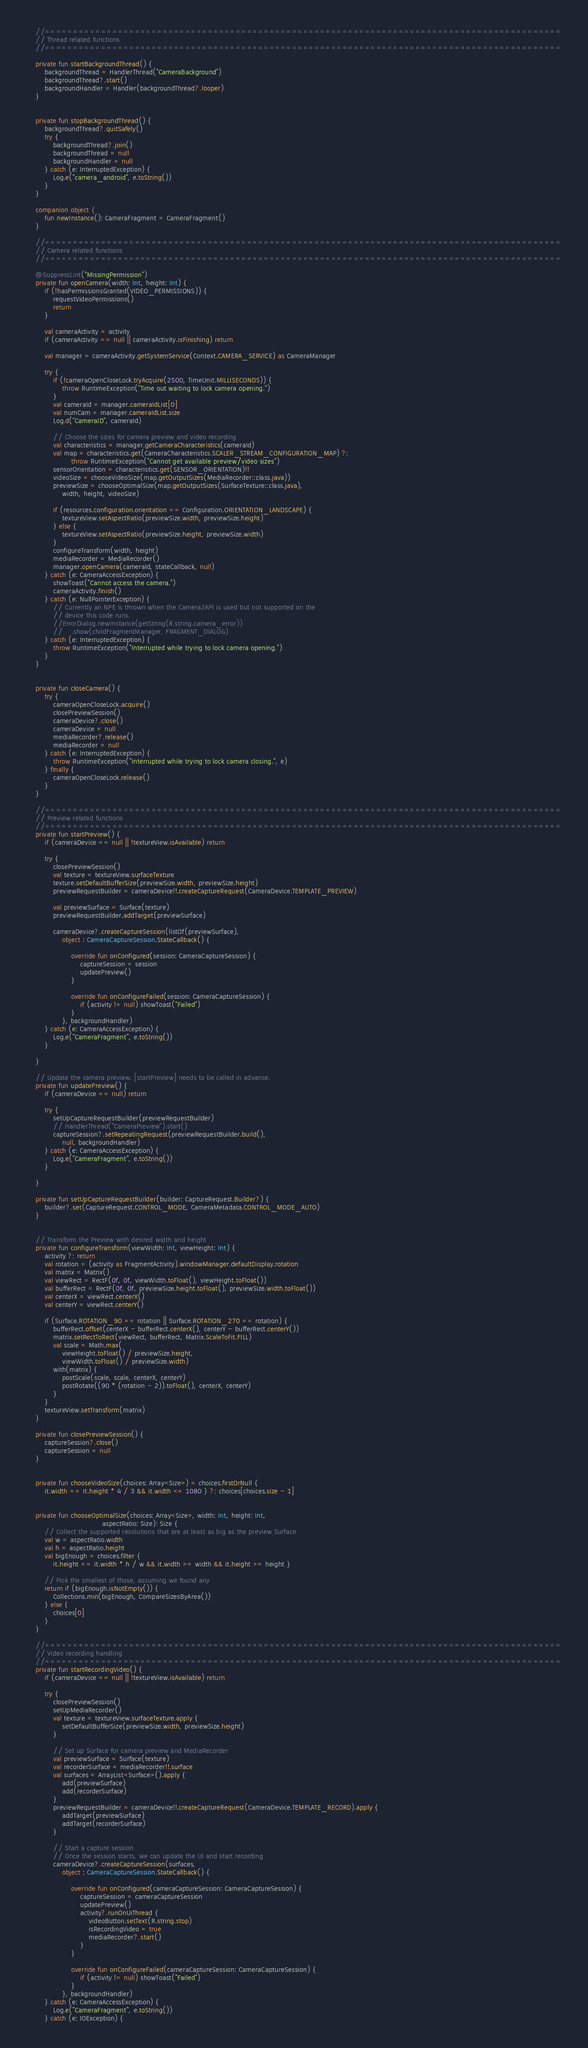Convert code to text. <code><loc_0><loc_0><loc_500><loc_500><_Kotlin_>    //============================================================================================
    // Thread related functions
    //============================================================================================

    private fun startBackgroundThread() {
        backgroundThread = HandlerThread("CameraBackground")
        backgroundThread?.start()
        backgroundHandler = Handler(backgroundThread?.looper)
    }


    private fun stopBackgroundThread() {
        backgroundThread?.quitSafely()
        try {
            backgroundThread?.join()
            backgroundThread = null
            backgroundHandler = null
        } catch (e: InterruptedException) {
            Log.e("camera_android", e.toString())
        }
    }

    companion object {
        fun newInstance(): CameraFragment = CameraFragment()
    }

    //============================================================================================
    // Camera related functions
    //============================================================================================

    @SuppressLint("MissingPermission")
    private fun openCamera(width: Int, height: Int) {
        if (!hasPermissionsGranted(VIDEO_PERMISSIONS)) {
            requestVideoPermissions()
            return
        }

        val cameraActivity = activity
        if (cameraActivity == null || cameraActivity.isFinishing) return

        val manager = cameraActivity.getSystemService(Context.CAMERA_SERVICE) as CameraManager

        try {
            if (!cameraOpenCloseLock.tryAcquire(2500, TimeUnit.MILLISECONDS)) {
                throw RuntimeException("Time out waiting to lock camera opening.")
            }
            val cameraId = manager.cameraIdList[0]
            val numCam = manager.cameraIdList.size
            Log.d("CameraID", cameraId)

            // Choose the sizes for camera preview and video recording
            val characteristics = manager.getCameraCharacteristics(cameraId)
            val map = characteristics.get(CameraCharacteristics.SCALER_STREAM_CONFIGURATION_MAP) ?:
                    throw RuntimeException("Cannot get available preview/video sizes")
            sensorOrientation = characteristics.get(SENSOR_ORIENTATION)!!
            videoSize = chooseVideoSize(map.getOutputSizes(MediaRecorder::class.java))
            previewSize = chooseOptimalSize(map.getOutputSizes(SurfaceTexture::class.java),
                width, height, videoSize)

            if (resources.configuration.orientation == Configuration.ORIENTATION_LANDSCAPE) {
                textureView.setAspectRatio(previewSize.width, previewSize.height)
            } else {
                textureView.setAspectRatio(previewSize.height, previewSize.width)
            }
            configureTransform(width, height)
            mediaRecorder = MediaRecorder()
            manager.openCamera(cameraId, stateCallback, null)
        } catch (e: CameraAccessException) {
            showToast("Cannot access the camera.")
            cameraActivity.finish()
        } catch (e: NullPointerException) {
            // Currently an NPE is thrown when the Camera2API is used but not supported on the
            // device this code runs.
            //ErrorDialog.newInstance(getString(R.string.camera_error))
            //    .show(childFragmentManager, FRAGMENT_DIALOG)
        } catch (e: InterruptedException) {
            throw RuntimeException("Interrupted while trying to lock camera opening.")
        }
    }


    private fun closeCamera() {
        try {
            cameraOpenCloseLock.acquire()
            closePreviewSession()
            cameraDevice?.close()
            cameraDevice = null
            mediaRecorder?.release()
            mediaRecorder = null
        } catch (e: InterruptedException) {
            throw RuntimeException("Interrupted while trying to lock camera closing.", e)
        } finally {
            cameraOpenCloseLock.release()
        }
    }

    //============================================================================================
    // Preview related functions
    //============================================================================================
    private fun startPreview() {
        if (cameraDevice == null || !textureView.isAvailable) return

        try {
            closePreviewSession()
            val texture = textureView.surfaceTexture
            texture.setDefaultBufferSize(previewSize.width, previewSize.height)
            previewRequestBuilder = cameraDevice!!.createCaptureRequest(CameraDevice.TEMPLATE_PREVIEW)

            val previewSurface = Surface(texture)
            previewRequestBuilder.addTarget(previewSurface)

            cameraDevice?.createCaptureSession(listOf(previewSurface),
                object : CameraCaptureSession.StateCallback() {

                    override fun onConfigured(session: CameraCaptureSession) {
                        captureSession = session
                        updatePreview()
                    }

                    override fun onConfigureFailed(session: CameraCaptureSession) {
                        if (activity != null) showToast("Failed")
                    }
                }, backgroundHandler)
        } catch (e: CameraAccessException) {
            Log.e("CameraFragment", e.toString())
        }

    }

    // Update the camera preview. [startPreview] needs to be called in advance.
    private fun updatePreview() {
        if (cameraDevice == null) return

        try {
            setUpCaptureRequestBuilder(previewRequestBuilder)
            // HandlerThread("CameraPreview").start()
            captureSession?.setRepeatingRequest(previewRequestBuilder.build(),
                null, backgroundHandler)
        } catch (e: CameraAccessException) {
            Log.e("CameraFragment", e.toString())
        }

    }

    private fun setUpCaptureRequestBuilder(builder: CaptureRequest.Builder?) {
        builder?.set(CaptureRequest.CONTROL_MODE, CameraMetadata.CONTROL_MODE_AUTO)
    }


    // Transform the Preview with desired width and height
    private fun configureTransform(viewWidth: Int, viewHeight: Int) {
        activity ?: return
        val rotation = (activity as FragmentActivity).windowManager.defaultDisplay.rotation
        val matrix = Matrix()
        val viewRect = RectF(0f, 0f, viewWidth.toFloat(), viewHeight.toFloat())
        val bufferRect = RectF(0f, 0f, previewSize.height.toFloat(), previewSize.width.toFloat())
        val centerX = viewRect.centerX()
        val centerY = viewRect.centerY()

        if (Surface.ROTATION_90 == rotation || Surface.ROTATION_270 == rotation) {
            bufferRect.offset(centerX - bufferRect.centerX(), centerY - bufferRect.centerY())
            matrix.setRectToRect(viewRect, bufferRect, Matrix.ScaleToFit.FILL)
            val scale = Math.max(
                viewHeight.toFloat() / previewSize.height,
                viewWidth.toFloat() / previewSize.width)
            with(matrix) {
                postScale(scale, scale, centerX, centerY)
                postRotate((90 * (rotation - 2)).toFloat(), centerX, centerY)
            }
        }
        textureView.setTransform(matrix)
    }

    private fun closePreviewSession() {
        captureSession?.close()
        captureSession = null
    }


    private fun chooseVideoSize(choices: Array<Size>) = choices.firstOrNull {
        it.width == it.height * 4 / 3 && it.width <= 1080 } ?: choices[choices.size - 1]


    private fun chooseOptimalSize(choices: Array<Size>, width: Int, height: Int,
                                  aspectRatio: Size): Size {
        // Collect the supported resolutions that are at least as big as the preview Surface
        val w = aspectRatio.width
        val h = aspectRatio.height
        val bigEnough = choices.filter {
            it.height == it.width * h / w && it.width >= width && it.height >= height }

        // Pick the smallest of those, assuming we found any
        return if (bigEnough.isNotEmpty()) {
            Collections.min(bigEnough, CompareSizesByArea())
        } else {
            choices[0]
        }
    }

    //============================================================================================
    // Video recording handling
    //============================================================================================
    private fun startRecordingVideo() {
        if (cameraDevice == null || !textureView.isAvailable) return

        try {
            closePreviewSession()
            setUpMediaRecorder()
            val texture = textureView.surfaceTexture.apply {
                setDefaultBufferSize(previewSize.width, previewSize.height)
            }

            // Set up Surface for camera preview and MediaRecorder
            val previewSurface = Surface(texture)
            val recorderSurface = mediaRecorder!!.surface
            val surfaces = ArrayList<Surface>().apply {
                add(previewSurface)
                add(recorderSurface)
            }
            previewRequestBuilder = cameraDevice!!.createCaptureRequest(CameraDevice.TEMPLATE_RECORD).apply {
                addTarget(previewSurface)
                addTarget(recorderSurface)
            }

            // Start a capture session
            // Once the session starts, we can update the UI and start recording
            cameraDevice?.createCaptureSession(surfaces,
                object : CameraCaptureSession.StateCallback() {

                    override fun onConfigured(cameraCaptureSession: CameraCaptureSession) {
                        captureSession = cameraCaptureSession
                        updatePreview()
                        activity?.runOnUiThread {
                            videoButton.setText(R.string.stop)
                            isRecordingVideo = true
                            mediaRecorder?.start()
                        }
                    }

                    override fun onConfigureFailed(cameraCaptureSession: CameraCaptureSession) {
                        if (activity != null) showToast("Failed")
                    }
                }, backgroundHandler)
        } catch (e: CameraAccessException) {
            Log.e("CameraFragment", e.toString())
        } catch (e: IOException) {</code> 